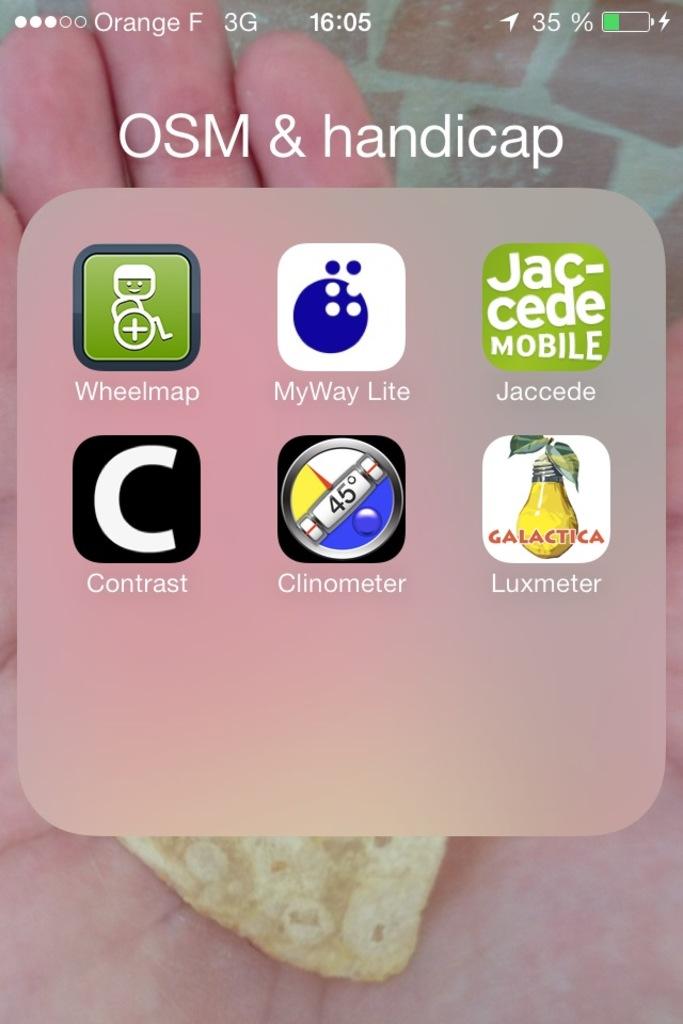What is the luxmeter app?
Provide a short and direct response. Unanswerable. How much battery left?
Provide a succinct answer. 35%. 